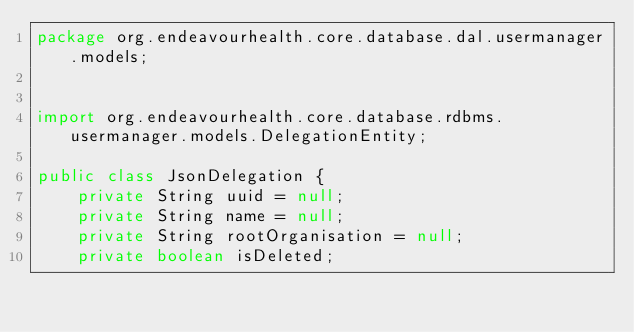<code> <loc_0><loc_0><loc_500><loc_500><_Java_>package org.endeavourhealth.core.database.dal.usermanager.models;


import org.endeavourhealth.core.database.rdbms.usermanager.models.DelegationEntity;

public class JsonDelegation {
    private String uuid = null;
    private String name = null;
    private String rootOrganisation = null;
    private boolean isDeleted;
</code> 